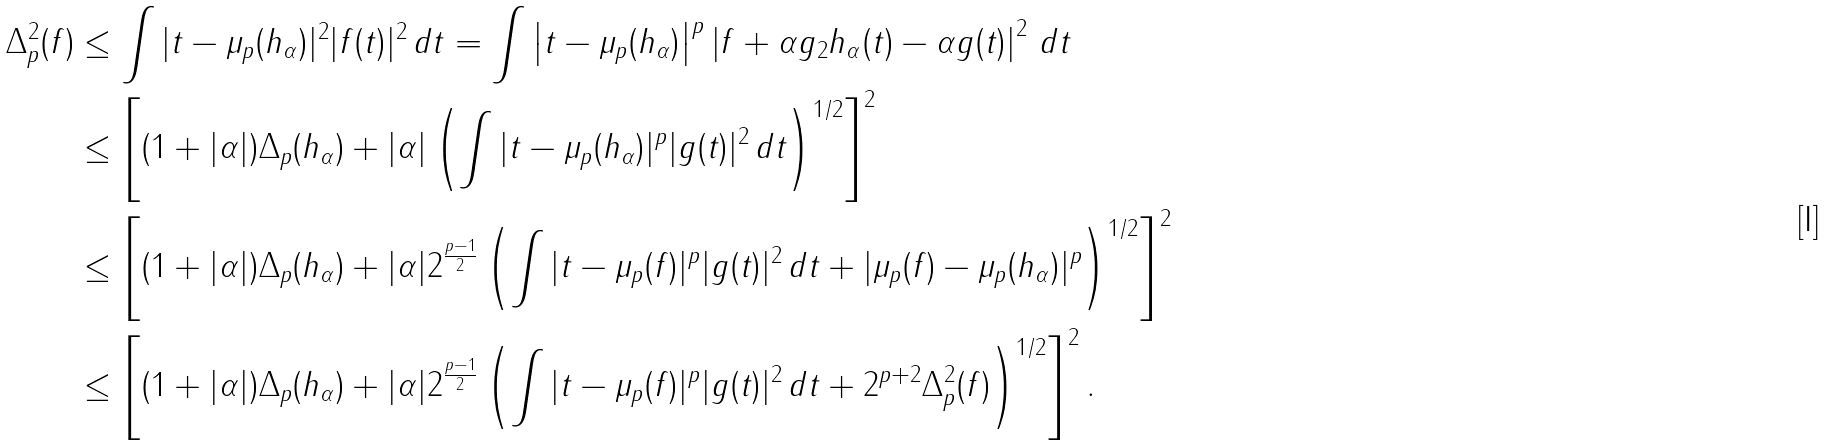<formula> <loc_0><loc_0><loc_500><loc_500>\Delta ^ { 2 } _ { p } ( f ) & \leq \int | t - \mu _ { p } ( h _ { \alpha } ) | ^ { 2 } | f ( t ) | ^ { 2 } \, d t = \int \left | t - \mu _ { p } ( h _ { \alpha } ) \right | ^ { p } \left | \| f + \alpha g \| _ { 2 } h _ { \alpha } ( t ) - \alpha g ( t ) \right | ^ { 2 } \, d t \\ & \leq \left [ ( 1 + | \alpha | ) \Delta _ { p } ( h _ { \alpha } ) + | \alpha | \left ( \int | t - \mu _ { p } ( h _ { \alpha } ) | ^ { p } | g ( t ) | ^ { 2 } \, d t \right ) ^ { 1 / 2 } \right ] ^ { 2 } \\ & \leq \left [ ( 1 + | \alpha | ) \Delta _ { p } ( h _ { \alpha } ) + | \alpha | 2 ^ { \frac { p - 1 } { 2 } } \left ( \int | t - \mu _ { p } ( f ) | ^ { p } | g ( t ) | ^ { 2 } \, d t + | \mu _ { p } ( f ) - \mu _ { p } ( h _ { \alpha } ) | ^ { p } \right ) ^ { 1 / 2 } \right ] ^ { 2 } \\ & \leq \left [ ( 1 + | \alpha | ) \Delta _ { p } ( h _ { \alpha } ) + | \alpha | 2 ^ { \frac { p - 1 } { 2 } } \left ( \int | t - \mu _ { p } ( f ) | ^ { p } | g ( t ) | ^ { 2 } \, d t + 2 ^ { p + 2 } \Delta ^ { 2 } _ { p } ( f ) \right ) ^ { 1 / 2 } \right ] ^ { 2 } .</formula> 